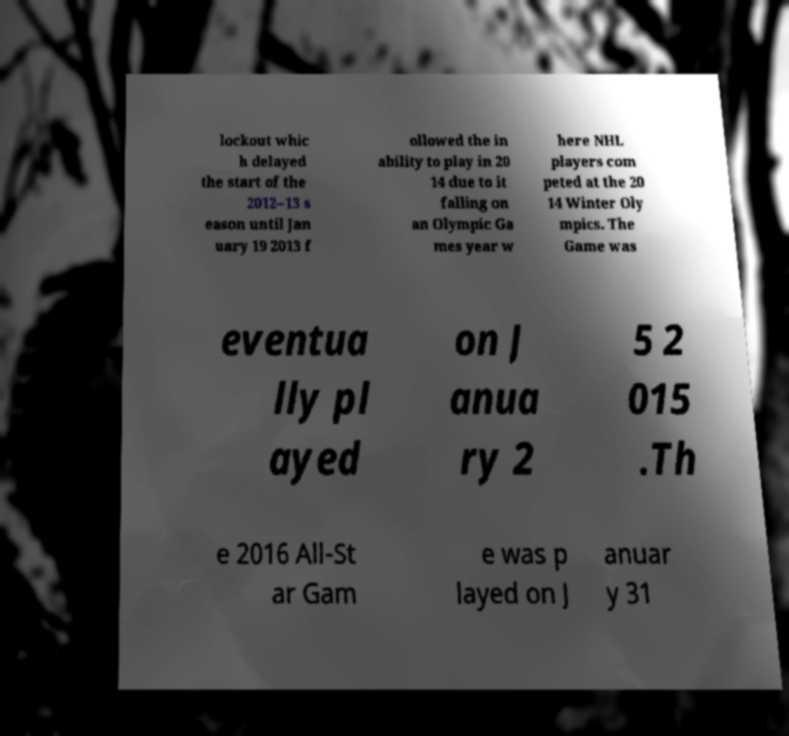Can you read and provide the text displayed in the image?This photo seems to have some interesting text. Can you extract and type it out for me? lockout whic h delayed the start of the 2012–13 s eason until Jan uary 19 2013 f ollowed the in ability to play in 20 14 due to it falling on an Olympic Ga mes year w here NHL players com peted at the 20 14 Winter Oly mpics. The Game was eventua lly pl ayed on J anua ry 2 5 2 015 .Th e 2016 All-St ar Gam e was p layed on J anuar y 31 